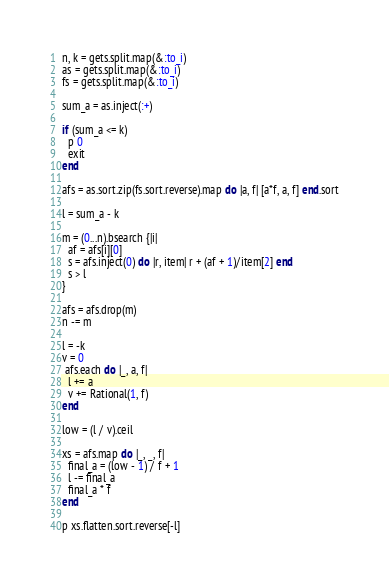Convert code to text. <code><loc_0><loc_0><loc_500><loc_500><_Ruby_>n, k = gets.split.map(&:to_i)
as = gets.split.map(&:to_i)
fs = gets.split.map(&:to_i)

sum_a = as.inject(:+)

if (sum_a <= k)
  p 0
  exit
end

afs = as.sort.zip(fs.sort.reverse).map do |a, f| [a*f, a, f] end.sort

l = sum_a - k

m = (0...n).bsearch {|i|
  af = afs[i][0]
  s = afs.inject(0) do |r, item| r + (af + 1)/item[2] end
  s > l
}

afs = afs.drop(m)
n -= m

l = -k
v = 0
 afs.each do |_, a, f|
  l += a
  v += Rational(1, f)
end

low = (l / v).ceil

xs = afs.map do |_, _, f|
  final_a = (low - 1) / f + 1
  l -= final_a
  final_a * f
end

p xs.flatten.sort.reverse[-l]</code> 